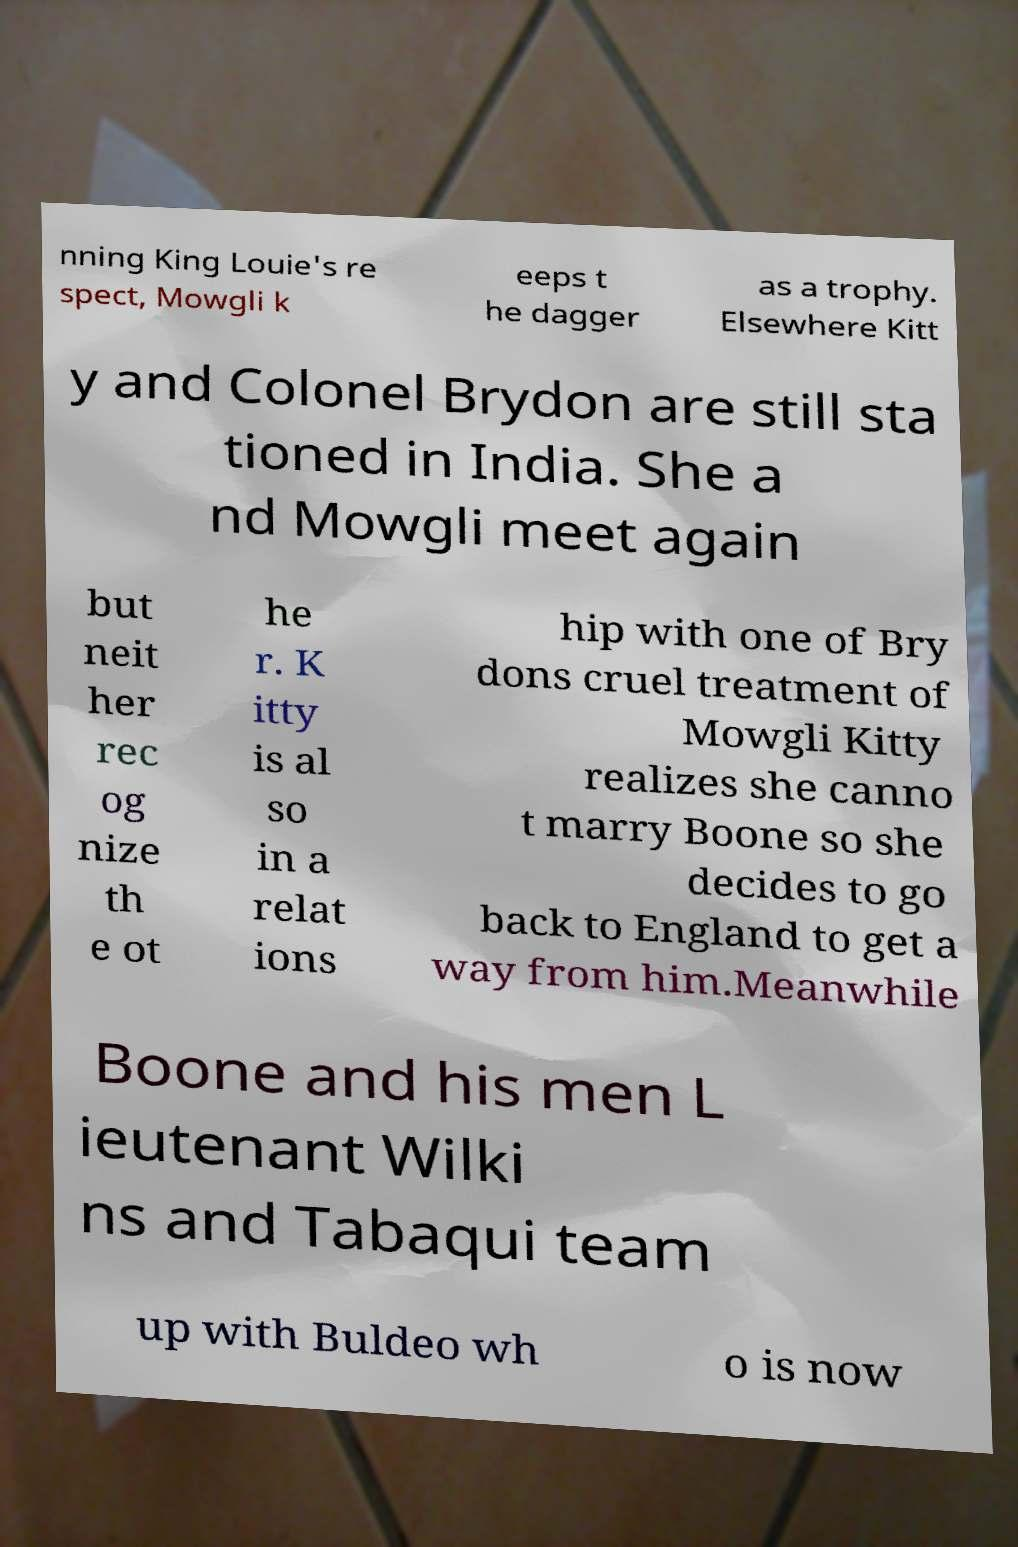What messages or text are displayed in this image? I need them in a readable, typed format. nning King Louie's re spect, Mowgli k eeps t he dagger as a trophy. Elsewhere Kitt y and Colonel Brydon are still sta tioned in India. She a nd Mowgli meet again but neit her rec og nize th e ot he r. K itty is al so in a relat ions hip with one of Bry dons cruel treatment of Mowgli Kitty realizes she canno t marry Boone so she decides to go back to England to get a way from him.Meanwhile Boone and his men L ieutenant Wilki ns and Tabaqui team up with Buldeo wh o is now 